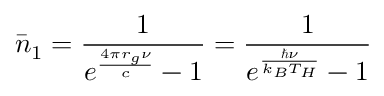<formula> <loc_0><loc_0><loc_500><loc_500>\bar { n } _ { 1 } = \frac { 1 } { e ^ { \frac { 4 \pi r _ { g } \nu } { c } } - 1 } = \frac { 1 } { e ^ { \frac { \hbar { \nu } } { k _ { B } T _ { H } } } - 1 }</formula> 